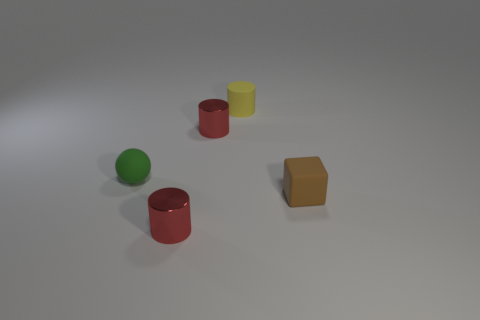Do the small rubber cylinder and the matte sphere have the same color?
Your answer should be very brief. No. Is the number of matte cylinders that are in front of the tiny brown thing less than the number of tiny blocks?
Provide a short and direct response. Yes. There is a tiny yellow thing that is made of the same material as the small brown thing; what is its shape?
Provide a succinct answer. Cylinder. What number of objects are red rubber blocks or yellow matte cylinders?
Offer a terse response. 1. There is a red cylinder that is right of the metallic thing in front of the green sphere; what is it made of?
Provide a succinct answer. Metal. Is there a tiny cylinder made of the same material as the brown cube?
Your answer should be compact. Yes. There is a tiny thing that is right of the tiny cylinder that is behind the tiny red cylinder behind the tiny rubber cube; what shape is it?
Ensure brevity in your answer.  Cube. What material is the tiny cube?
Offer a very short reply. Rubber. What is the color of the cylinder that is the same material as the tiny sphere?
Keep it short and to the point. Yellow. There is a tiny rubber thing that is to the right of the yellow thing; is there a tiny matte cube that is behind it?
Ensure brevity in your answer.  No. 